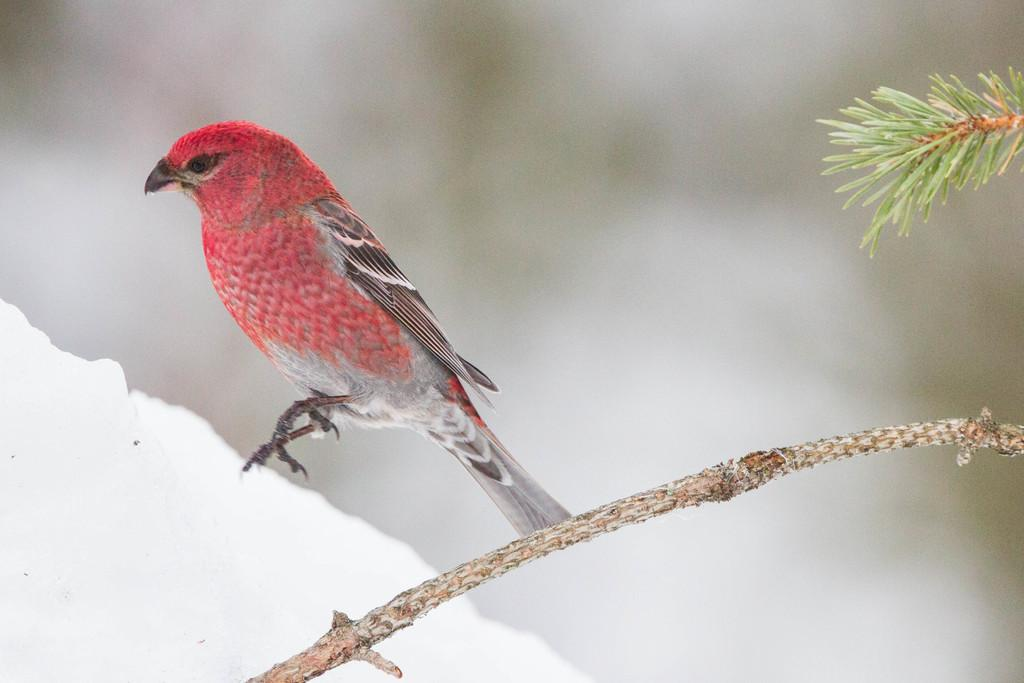What type of animal can be seen in the image? There is a bird in the image. Where is the bird located? The bird is on the snow. What else is present in the image besides the bird? There is a branch of a tree in the image. What type of meal is the bird eating in the image? There is no meal present in the image; the bird is simply standing on the snow. 